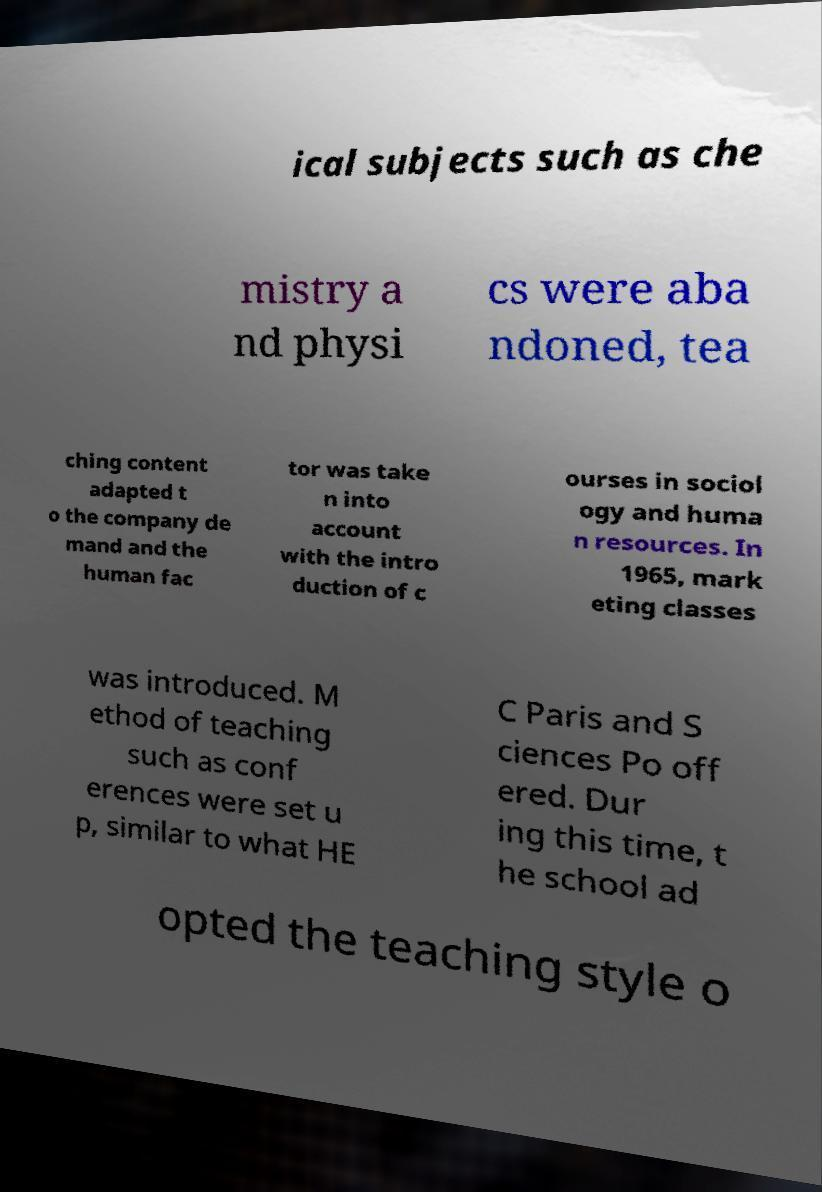Please identify and transcribe the text found in this image. ical subjects such as che mistry a nd physi cs were aba ndoned, tea ching content adapted t o the company de mand and the human fac tor was take n into account with the intro duction of c ourses in sociol ogy and huma n resources. In 1965, mark eting classes was introduced. M ethod of teaching such as conf erences were set u p, similar to what HE C Paris and S ciences Po off ered. Dur ing this time, t he school ad opted the teaching style o 